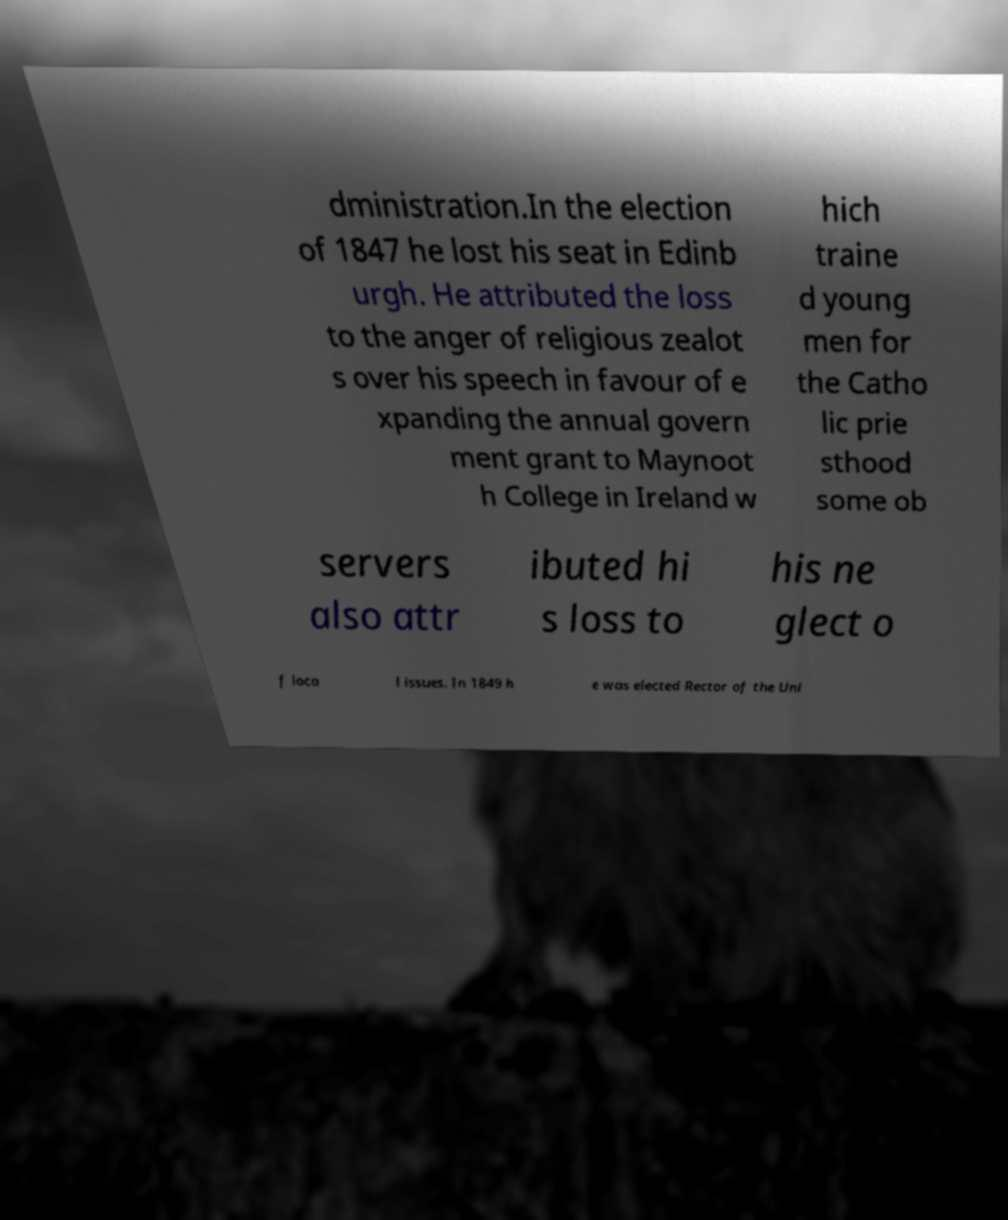There's text embedded in this image that I need extracted. Can you transcribe it verbatim? dministration.In the election of 1847 he lost his seat in Edinb urgh. He attributed the loss to the anger of religious zealot s over his speech in favour of e xpanding the annual govern ment grant to Maynoot h College in Ireland w hich traine d young men for the Catho lic prie sthood some ob servers also attr ibuted hi s loss to his ne glect o f loca l issues. In 1849 h e was elected Rector of the Uni 